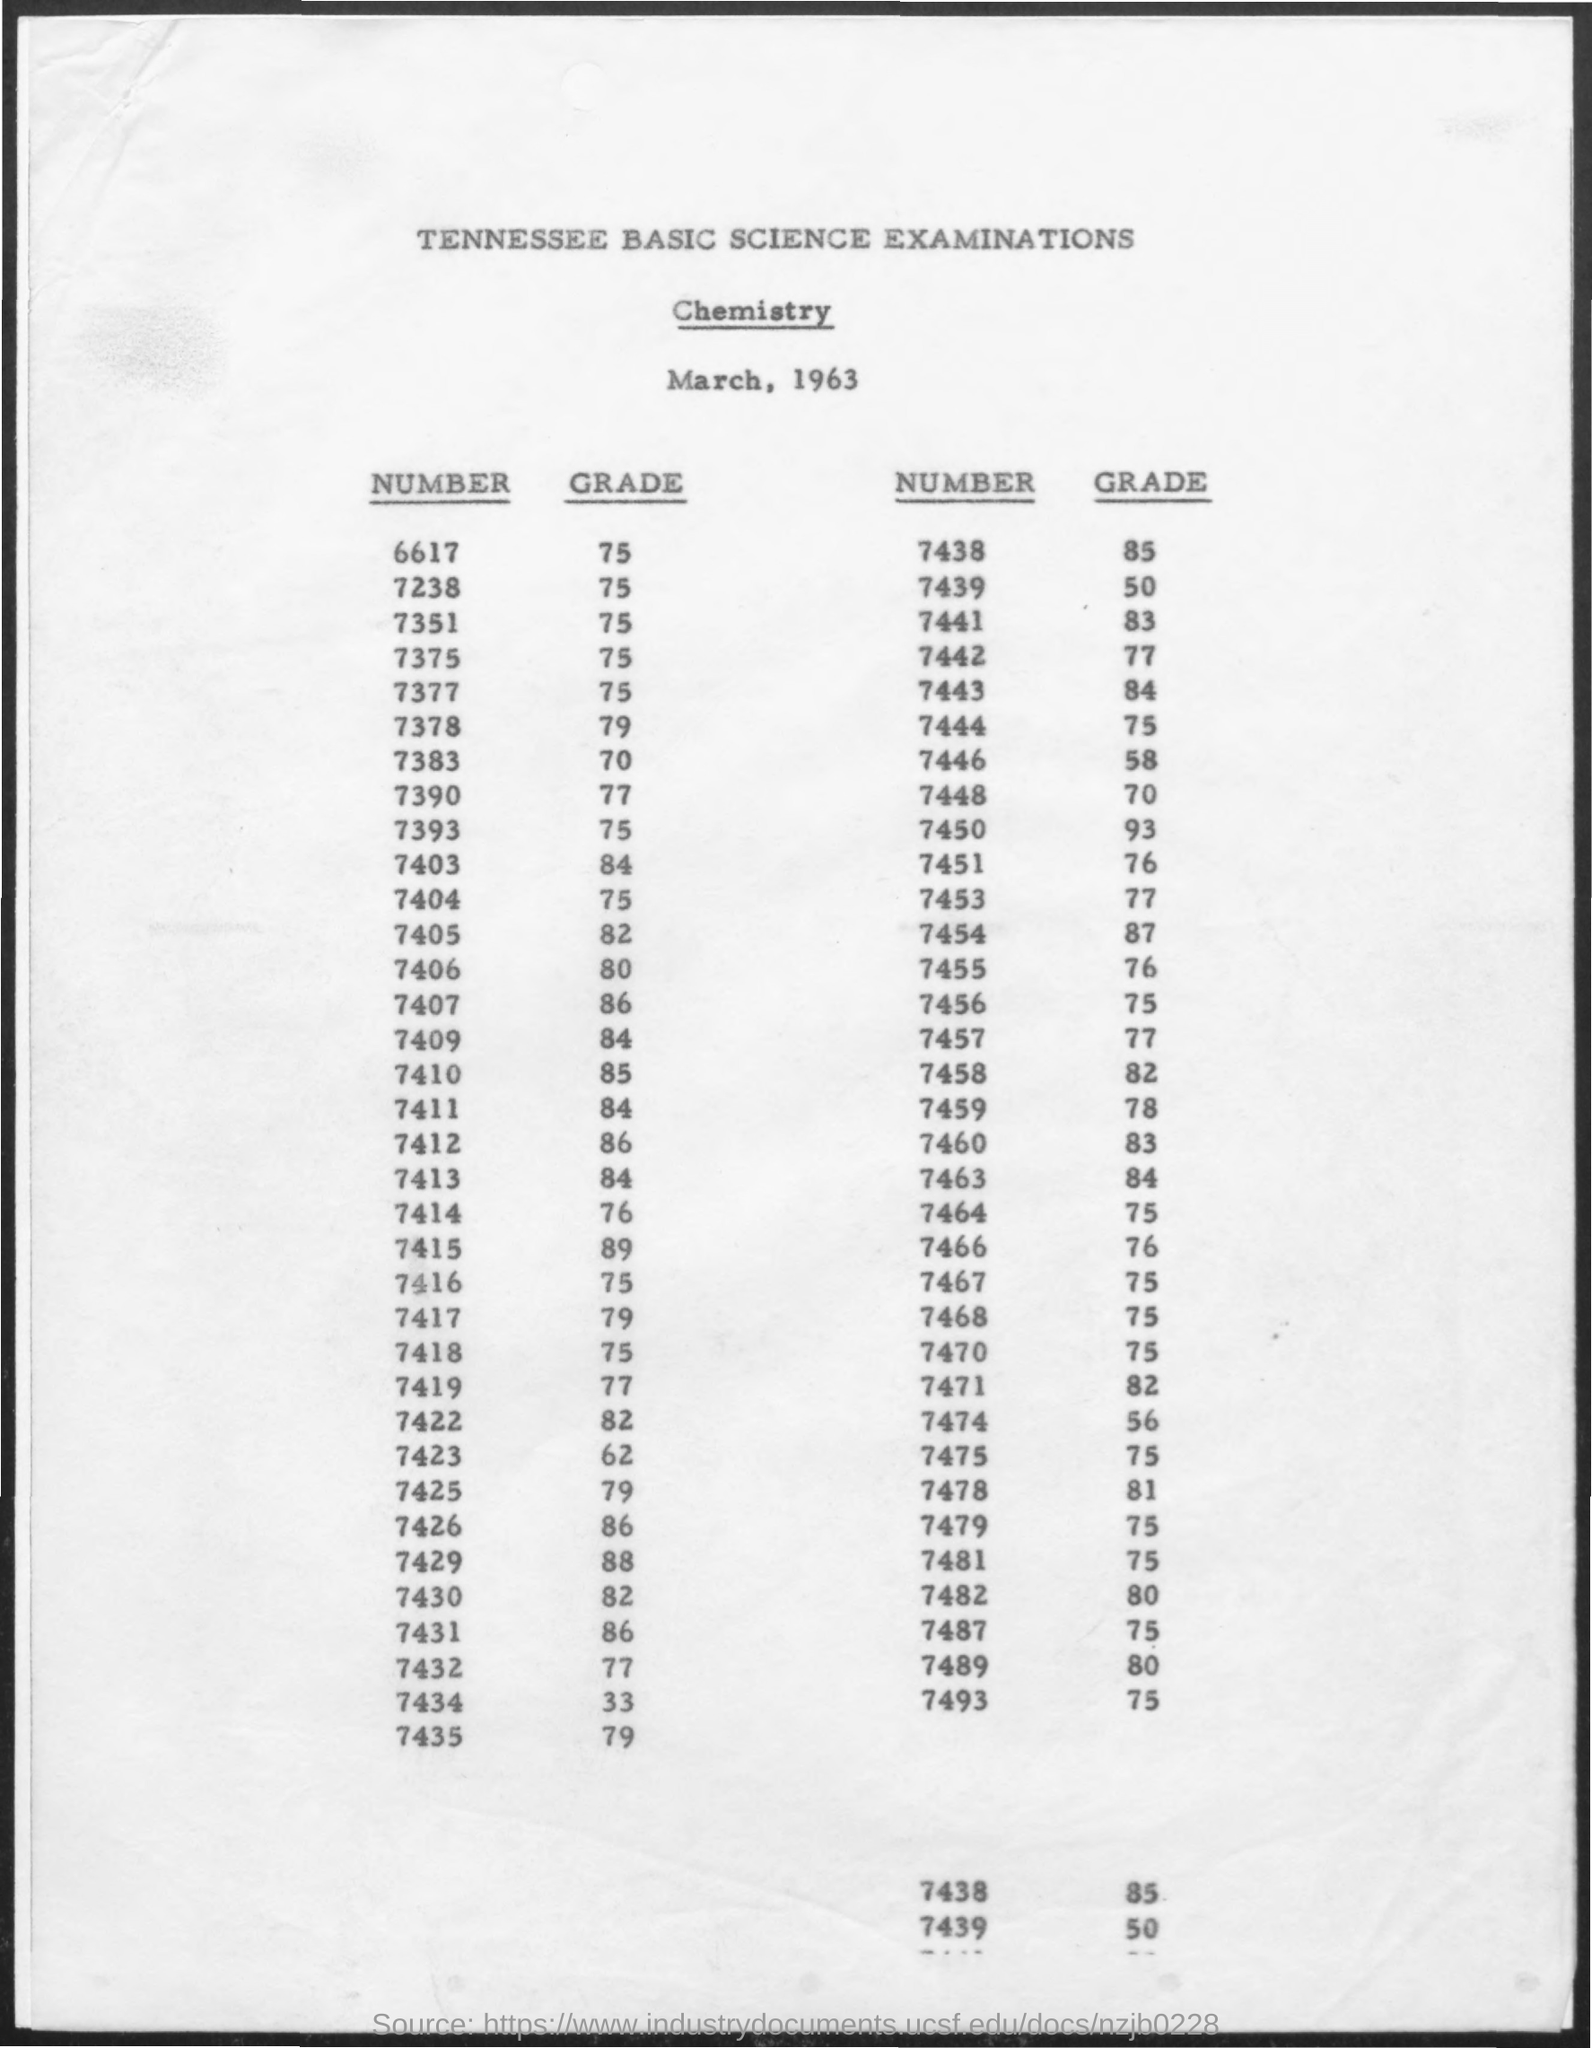Can you provide me with the grade for number 7459? Number 7459 received a grade of 83 on the chemistry exam. 